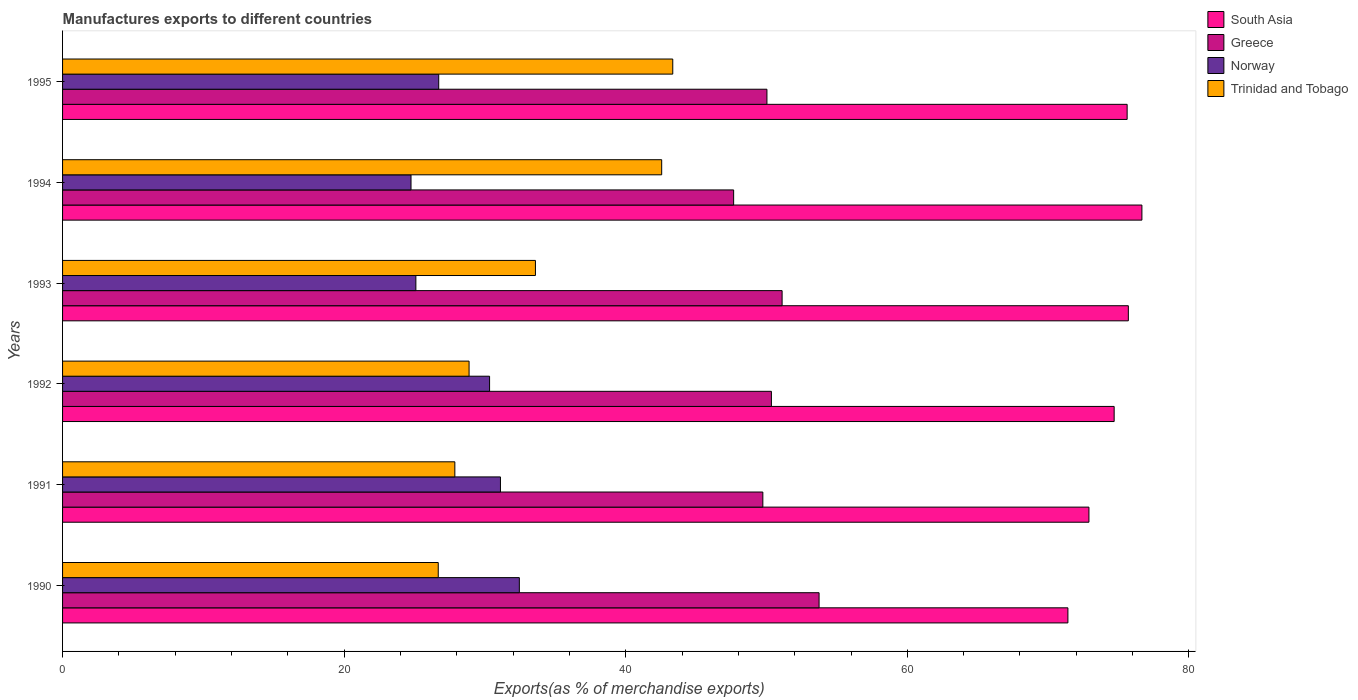How many different coloured bars are there?
Your answer should be compact. 4. How many groups of bars are there?
Offer a terse response. 6. How many bars are there on the 4th tick from the top?
Your answer should be compact. 4. How many bars are there on the 3rd tick from the bottom?
Make the answer very short. 4. In how many cases, is the number of bars for a given year not equal to the number of legend labels?
Provide a short and direct response. 0. What is the percentage of exports to different countries in South Asia in 1991?
Offer a very short reply. 72.9. Across all years, what is the maximum percentage of exports to different countries in South Asia?
Offer a very short reply. 76.66. Across all years, what is the minimum percentage of exports to different countries in Norway?
Offer a terse response. 24.75. In which year was the percentage of exports to different countries in Norway maximum?
Your response must be concise. 1990. What is the total percentage of exports to different countries in Norway in the graph?
Provide a succinct answer. 170.43. What is the difference between the percentage of exports to different countries in South Asia in 1991 and that in 1993?
Your answer should be very brief. -2.8. What is the difference between the percentage of exports to different countries in Greece in 1993 and the percentage of exports to different countries in Trinidad and Tobago in 1995?
Make the answer very short. 7.77. What is the average percentage of exports to different countries in South Asia per year?
Keep it short and to the point. 74.49. In the year 1990, what is the difference between the percentage of exports to different countries in South Asia and percentage of exports to different countries in Trinidad and Tobago?
Offer a very short reply. 44.72. In how many years, is the percentage of exports to different countries in Norway greater than 28 %?
Provide a short and direct response. 3. What is the ratio of the percentage of exports to different countries in South Asia in 1994 to that in 1995?
Provide a short and direct response. 1.01. What is the difference between the highest and the second highest percentage of exports to different countries in Trinidad and Tobago?
Give a very brief answer. 0.79. What is the difference between the highest and the lowest percentage of exports to different countries in South Asia?
Your answer should be compact. 5.25. In how many years, is the percentage of exports to different countries in Trinidad and Tobago greater than the average percentage of exports to different countries in Trinidad and Tobago taken over all years?
Ensure brevity in your answer.  2. Is it the case that in every year, the sum of the percentage of exports to different countries in Trinidad and Tobago and percentage of exports to different countries in South Asia is greater than the sum of percentage of exports to different countries in Norway and percentage of exports to different countries in Greece?
Offer a very short reply. Yes. What does the 3rd bar from the top in 1994 represents?
Your answer should be compact. Greece. What does the 3rd bar from the bottom in 1990 represents?
Keep it short and to the point. Norway. Is it the case that in every year, the sum of the percentage of exports to different countries in Trinidad and Tobago and percentage of exports to different countries in South Asia is greater than the percentage of exports to different countries in Norway?
Your answer should be very brief. Yes. What is the difference between two consecutive major ticks on the X-axis?
Provide a short and direct response. 20. Does the graph contain grids?
Offer a terse response. No. Where does the legend appear in the graph?
Ensure brevity in your answer.  Top right. How many legend labels are there?
Keep it short and to the point. 4. What is the title of the graph?
Keep it short and to the point. Manufactures exports to different countries. Does "Latvia" appear as one of the legend labels in the graph?
Provide a succinct answer. No. What is the label or title of the X-axis?
Offer a very short reply. Exports(as % of merchandise exports). What is the Exports(as % of merchandise exports) in South Asia in 1990?
Provide a succinct answer. 71.4. What is the Exports(as % of merchandise exports) in Greece in 1990?
Ensure brevity in your answer.  53.73. What is the Exports(as % of merchandise exports) in Norway in 1990?
Provide a short and direct response. 32.44. What is the Exports(as % of merchandise exports) in Trinidad and Tobago in 1990?
Give a very brief answer. 26.68. What is the Exports(as % of merchandise exports) in South Asia in 1991?
Make the answer very short. 72.9. What is the Exports(as % of merchandise exports) in Greece in 1991?
Provide a short and direct response. 49.74. What is the Exports(as % of merchandise exports) in Norway in 1991?
Your response must be concise. 31.1. What is the Exports(as % of merchandise exports) in Trinidad and Tobago in 1991?
Keep it short and to the point. 27.86. What is the Exports(as % of merchandise exports) in South Asia in 1992?
Your answer should be compact. 74.69. What is the Exports(as % of merchandise exports) in Greece in 1992?
Offer a very short reply. 50.34. What is the Exports(as % of merchandise exports) of Norway in 1992?
Your response must be concise. 30.33. What is the Exports(as % of merchandise exports) of Trinidad and Tobago in 1992?
Offer a very short reply. 28.87. What is the Exports(as % of merchandise exports) in South Asia in 1993?
Ensure brevity in your answer.  75.7. What is the Exports(as % of merchandise exports) in Greece in 1993?
Provide a short and direct response. 51.1. What is the Exports(as % of merchandise exports) of Norway in 1993?
Ensure brevity in your answer.  25.09. What is the Exports(as % of merchandise exports) of Trinidad and Tobago in 1993?
Provide a succinct answer. 33.58. What is the Exports(as % of merchandise exports) of South Asia in 1994?
Your answer should be compact. 76.66. What is the Exports(as % of merchandise exports) of Greece in 1994?
Your answer should be compact. 47.66. What is the Exports(as % of merchandise exports) in Norway in 1994?
Provide a short and direct response. 24.75. What is the Exports(as % of merchandise exports) in Trinidad and Tobago in 1994?
Your response must be concise. 42.55. What is the Exports(as % of merchandise exports) of South Asia in 1995?
Provide a short and direct response. 75.61. What is the Exports(as % of merchandise exports) in Greece in 1995?
Offer a terse response. 50.03. What is the Exports(as % of merchandise exports) of Norway in 1995?
Provide a short and direct response. 26.72. What is the Exports(as % of merchandise exports) of Trinidad and Tobago in 1995?
Your answer should be compact. 43.34. Across all years, what is the maximum Exports(as % of merchandise exports) in South Asia?
Your answer should be compact. 76.66. Across all years, what is the maximum Exports(as % of merchandise exports) in Greece?
Your response must be concise. 53.73. Across all years, what is the maximum Exports(as % of merchandise exports) in Norway?
Offer a very short reply. 32.44. Across all years, what is the maximum Exports(as % of merchandise exports) in Trinidad and Tobago?
Your answer should be very brief. 43.34. Across all years, what is the minimum Exports(as % of merchandise exports) of South Asia?
Provide a short and direct response. 71.4. Across all years, what is the minimum Exports(as % of merchandise exports) in Greece?
Give a very brief answer. 47.66. Across all years, what is the minimum Exports(as % of merchandise exports) of Norway?
Ensure brevity in your answer.  24.75. Across all years, what is the minimum Exports(as % of merchandise exports) in Trinidad and Tobago?
Your response must be concise. 26.68. What is the total Exports(as % of merchandise exports) in South Asia in the graph?
Ensure brevity in your answer.  446.95. What is the total Exports(as % of merchandise exports) in Greece in the graph?
Provide a short and direct response. 302.61. What is the total Exports(as % of merchandise exports) in Norway in the graph?
Your response must be concise. 170.43. What is the total Exports(as % of merchandise exports) of Trinidad and Tobago in the graph?
Your answer should be compact. 202.89. What is the difference between the Exports(as % of merchandise exports) in South Asia in 1990 and that in 1991?
Provide a short and direct response. -1.49. What is the difference between the Exports(as % of merchandise exports) in Greece in 1990 and that in 1991?
Offer a terse response. 3.99. What is the difference between the Exports(as % of merchandise exports) of Norway in 1990 and that in 1991?
Give a very brief answer. 1.34. What is the difference between the Exports(as % of merchandise exports) in Trinidad and Tobago in 1990 and that in 1991?
Offer a terse response. -1.18. What is the difference between the Exports(as % of merchandise exports) of South Asia in 1990 and that in 1992?
Your answer should be very brief. -3.28. What is the difference between the Exports(as % of merchandise exports) in Greece in 1990 and that in 1992?
Provide a short and direct response. 3.39. What is the difference between the Exports(as % of merchandise exports) of Norway in 1990 and that in 1992?
Ensure brevity in your answer.  2.11. What is the difference between the Exports(as % of merchandise exports) in Trinidad and Tobago in 1990 and that in 1992?
Offer a very short reply. -2.19. What is the difference between the Exports(as % of merchandise exports) in South Asia in 1990 and that in 1993?
Ensure brevity in your answer.  -4.29. What is the difference between the Exports(as % of merchandise exports) in Greece in 1990 and that in 1993?
Offer a terse response. 2.63. What is the difference between the Exports(as % of merchandise exports) in Norway in 1990 and that in 1993?
Provide a succinct answer. 7.35. What is the difference between the Exports(as % of merchandise exports) of Trinidad and Tobago in 1990 and that in 1993?
Your answer should be very brief. -6.9. What is the difference between the Exports(as % of merchandise exports) in South Asia in 1990 and that in 1994?
Offer a terse response. -5.25. What is the difference between the Exports(as % of merchandise exports) of Greece in 1990 and that in 1994?
Make the answer very short. 6.07. What is the difference between the Exports(as % of merchandise exports) in Norway in 1990 and that in 1994?
Your answer should be compact. 7.69. What is the difference between the Exports(as % of merchandise exports) of Trinidad and Tobago in 1990 and that in 1994?
Make the answer very short. -15.87. What is the difference between the Exports(as % of merchandise exports) in South Asia in 1990 and that in 1995?
Offer a very short reply. -4.21. What is the difference between the Exports(as % of merchandise exports) of Greece in 1990 and that in 1995?
Offer a very short reply. 3.7. What is the difference between the Exports(as % of merchandise exports) of Norway in 1990 and that in 1995?
Ensure brevity in your answer.  5.73. What is the difference between the Exports(as % of merchandise exports) of Trinidad and Tobago in 1990 and that in 1995?
Make the answer very short. -16.66. What is the difference between the Exports(as % of merchandise exports) in South Asia in 1991 and that in 1992?
Offer a terse response. -1.79. What is the difference between the Exports(as % of merchandise exports) of Greece in 1991 and that in 1992?
Give a very brief answer. -0.61. What is the difference between the Exports(as % of merchandise exports) in Norway in 1991 and that in 1992?
Keep it short and to the point. 0.77. What is the difference between the Exports(as % of merchandise exports) of Trinidad and Tobago in 1991 and that in 1992?
Ensure brevity in your answer.  -1.01. What is the difference between the Exports(as % of merchandise exports) in South Asia in 1991 and that in 1993?
Your answer should be compact. -2.8. What is the difference between the Exports(as % of merchandise exports) in Greece in 1991 and that in 1993?
Ensure brevity in your answer.  -1.37. What is the difference between the Exports(as % of merchandise exports) in Norway in 1991 and that in 1993?
Your answer should be compact. 6.01. What is the difference between the Exports(as % of merchandise exports) of Trinidad and Tobago in 1991 and that in 1993?
Your answer should be very brief. -5.72. What is the difference between the Exports(as % of merchandise exports) in South Asia in 1991 and that in 1994?
Keep it short and to the point. -3.76. What is the difference between the Exports(as % of merchandise exports) in Greece in 1991 and that in 1994?
Keep it short and to the point. 2.07. What is the difference between the Exports(as % of merchandise exports) of Norway in 1991 and that in 1994?
Provide a succinct answer. 6.35. What is the difference between the Exports(as % of merchandise exports) in Trinidad and Tobago in 1991 and that in 1994?
Give a very brief answer. -14.69. What is the difference between the Exports(as % of merchandise exports) in South Asia in 1991 and that in 1995?
Your response must be concise. -2.71. What is the difference between the Exports(as % of merchandise exports) in Greece in 1991 and that in 1995?
Your answer should be very brief. -0.29. What is the difference between the Exports(as % of merchandise exports) of Norway in 1991 and that in 1995?
Provide a short and direct response. 4.38. What is the difference between the Exports(as % of merchandise exports) of Trinidad and Tobago in 1991 and that in 1995?
Your answer should be compact. -15.48. What is the difference between the Exports(as % of merchandise exports) in South Asia in 1992 and that in 1993?
Offer a terse response. -1.01. What is the difference between the Exports(as % of merchandise exports) in Greece in 1992 and that in 1993?
Your answer should be very brief. -0.76. What is the difference between the Exports(as % of merchandise exports) of Norway in 1992 and that in 1993?
Provide a succinct answer. 5.23. What is the difference between the Exports(as % of merchandise exports) of Trinidad and Tobago in 1992 and that in 1993?
Offer a terse response. -4.71. What is the difference between the Exports(as % of merchandise exports) of South Asia in 1992 and that in 1994?
Offer a very short reply. -1.97. What is the difference between the Exports(as % of merchandise exports) in Greece in 1992 and that in 1994?
Offer a terse response. 2.68. What is the difference between the Exports(as % of merchandise exports) of Norway in 1992 and that in 1994?
Provide a succinct answer. 5.58. What is the difference between the Exports(as % of merchandise exports) of Trinidad and Tobago in 1992 and that in 1994?
Your answer should be compact. -13.68. What is the difference between the Exports(as % of merchandise exports) of South Asia in 1992 and that in 1995?
Make the answer very short. -0.92. What is the difference between the Exports(as % of merchandise exports) in Greece in 1992 and that in 1995?
Offer a terse response. 0.32. What is the difference between the Exports(as % of merchandise exports) of Norway in 1992 and that in 1995?
Your answer should be compact. 3.61. What is the difference between the Exports(as % of merchandise exports) of Trinidad and Tobago in 1992 and that in 1995?
Provide a short and direct response. -14.47. What is the difference between the Exports(as % of merchandise exports) of South Asia in 1993 and that in 1994?
Your answer should be compact. -0.96. What is the difference between the Exports(as % of merchandise exports) in Greece in 1993 and that in 1994?
Give a very brief answer. 3.44. What is the difference between the Exports(as % of merchandise exports) in Norway in 1993 and that in 1994?
Offer a very short reply. 0.35. What is the difference between the Exports(as % of merchandise exports) of Trinidad and Tobago in 1993 and that in 1994?
Your answer should be very brief. -8.97. What is the difference between the Exports(as % of merchandise exports) in South Asia in 1993 and that in 1995?
Ensure brevity in your answer.  0.09. What is the difference between the Exports(as % of merchandise exports) of Greece in 1993 and that in 1995?
Give a very brief answer. 1.08. What is the difference between the Exports(as % of merchandise exports) in Norway in 1993 and that in 1995?
Give a very brief answer. -1.62. What is the difference between the Exports(as % of merchandise exports) of Trinidad and Tobago in 1993 and that in 1995?
Your answer should be compact. -9.75. What is the difference between the Exports(as % of merchandise exports) of South Asia in 1994 and that in 1995?
Make the answer very short. 1.05. What is the difference between the Exports(as % of merchandise exports) in Greece in 1994 and that in 1995?
Keep it short and to the point. -2.36. What is the difference between the Exports(as % of merchandise exports) of Norway in 1994 and that in 1995?
Offer a terse response. -1.97. What is the difference between the Exports(as % of merchandise exports) of Trinidad and Tobago in 1994 and that in 1995?
Offer a terse response. -0.79. What is the difference between the Exports(as % of merchandise exports) in South Asia in 1990 and the Exports(as % of merchandise exports) in Greece in 1991?
Keep it short and to the point. 21.67. What is the difference between the Exports(as % of merchandise exports) in South Asia in 1990 and the Exports(as % of merchandise exports) in Norway in 1991?
Your answer should be very brief. 40.3. What is the difference between the Exports(as % of merchandise exports) in South Asia in 1990 and the Exports(as % of merchandise exports) in Trinidad and Tobago in 1991?
Offer a very short reply. 43.54. What is the difference between the Exports(as % of merchandise exports) in Greece in 1990 and the Exports(as % of merchandise exports) in Norway in 1991?
Give a very brief answer. 22.63. What is the difference between the Exports(as % of merchandise exports) of Greece in 1990 and the Exports(as % of merchandise exports) of Trinidad and Tobago in 1991?
Your answer should be compact. 25.87. What is the difference between the Exports(as % of merchandise exports) of Norway in 1990 and the Exports(as % of merchandise exports) of Trinidad and Tobago in 1991?
Provide a short and direct response. 4.58. What is the difference between the Exports(as % of merchandise exports) in South Asia in 1990 and the Exports(as % of merchandise exports) in Greece in 1992?
Provide a succinct answer. 21.06. What is the difference between the Exports(as % of merchandise exports) of South Asia in 1990 and the Exports(as % of merchandise exports) of Norway in 1992?
Your answer should be compact. 41.08. What is the difference between the Exports(as % of merchandise exports) in South Asia in 1990 and the Exports(as % of merchandise exports) in Trinidad and Tobago in 1992?
Provide a short and direct response. 42.53. What is the difference between the Exports(as % of merchandise exports) of Greece in 1990 and the Exports(as % of merchandise exports) of Norway in 1992?
Make the answer very short. 23.4. What is the difference between the Exports(as % of merchandise exports) in Greece in 1990 and the Exports(as % of merchandise exports) in Trinidad and Tobago in 1992?
Make the answer very short. 24.86. What is the difference between the Exports(as % of merchandise exports) of Norway in 1990 and the Exports(as % of merchandise exports) of Trinidad and Tobago in 1992?
Offer a terse response. 3.57. What is the difference between the Exports(as % of merchandise exports) of South Asia in 1990 and the Exports(as % of merchandise exports) of Greece in 1993?
Keep it short and to the point. 20.3. What is the difference between the Exports(as % of merchandise exports) of South Asia in 1990 and the Exports(as % of merchandise exports) of Norway in 1993?
Your answer should be very brief. 46.31. What is the difference between the Exports(as % of merchandise exports) of South Asia in 1990 and the Exports(as % of merchandise exports) of Trinidad and Tobago in 1993?
Your response must be concise. 37.82. What is the difference between the Exports(as % of merchandise exports) of Greece in 1990 and the Exports(as % of merchandise exports) of Norway in 1993?
Offer a very short reply. 28.64. What is the difference between the Exports(as % of merchandise exports) of Greece in 1990 and the Exports(as % of merchandise exports) of Trinidad and Tobago in 1993?
Offer a terse response. 20.15. What is the difference between the Exports(as % of merchandise exports) of Norway in 1990 and the Exports(as % of merchandise exports) of Trinidad and Tobago in 1993?
Make the answer very short. -1.14. What is the difference between the Exports(as % of merchandise exports) in South Asia in 1990 and the Exports(as % of merchandise exports) in Greece in 1994?
Ensure brevity in your answer.  23.74. What is the difference between the Exports(as % of merchandise exports) in South Asia in 1990 and the Exports(as % of merchandise exports) in Norway in 1994?
Provide a short and direct response. 46.66. What is the difference between the Exports(as % of merchandise exports) of South Asia in 1990 and the Exports(as % of merchandise exports) of Trinidad and Tobago in 1994?
Offer a terse response. 28.85. What is the difference between the Exports(as % of merchandise exports) in Greece in 1990 and the Exports(as % of merchandise exports) in Norway in 1994?
Ensure brevity in your answer.  28.98. What is the difference between the Exports(as % of merchandise exports) in Greece in 1990 and the Exports(as % of merchandise exports) in Trinidad and Tobago in 1994?
Ensure brevity in your answer.  11.18. What is the difference between the Exports(as % of merchandise exports) in Norway in 1990 and the Exports(as % of merchandise exports) in Trinidad and Tobago in 1994?
Provide a short and direct response. -10.11. What is the difference between the Exports(as % of merchandise exports) of South Asia in 1990 and the Exports(as % of merchandise exports) of Greece in 1995?
Provide a short and direct response. 21.38. What is the difference between the Exports(as % of merchandise exports) in South Asia in 1990 and the Exports(as % of merchandise exports) in Norway in 1995?
Give a very brief answer. 44.69. What is the difference between the Exports(as % of merchandise exports) of South Asia in 1990 and the Exports(as % of merchandise exports) of Trinidad and Tobago in 1995?
Provide a succinct answer. 28.07. What is the difference between the Exports(as % of merchandise exports) of Greece in 1990 and the Exports(as % of merchandise exports) of Norway in 1995?
Your answer should be very brief. 27.01. What is the difference between the Exports(as % of merchandise exports) of Greece in 1990 and the Exports(as % of merchandise exports) of Trinidad and Tobago in 1995?
Your answer should be very brief. 10.39. What is the difference between the Exports(as % of merchandise exports) in Norway in 1990 and the Exports(as % of merchandise exports) in Trinidad and Tobago in 1995?
Make the answer very short. -10.9. What is the difference between the Exports(as % of merchandise exports) of South Asia in 1991 and the Exports(as % of merchandise exports) of Greece in 1992?
Provide a short and direct response. 22.55. What is the difference between the Exports(as % of merchandise exports) in South Asia in 1991 and the Exports(as % of merchandise exports) in Norway in 1992?
Ensure brevity in your answer.  42.57. What is the difference between the Exports(as % of merchandise exports) of South Asia in 1991 and the Exports(as % of merchandise exports) of Trinidad and Tobago in 1992?
Your answer should be very brief. 44.02. What is the difference between the Exports(as % of merchandise exports) of Greece in 1991 and the Exports(as % of merchandise exports) of Norway in 1992?
Your answer should be very brief. 19.41. What is the difference between the Exports(as % of merchandise exports) of Greece in 1991 and the Exports(as % of merchandise exports) of Trinidad and Tobago in 1992?
Ensure brevity in your answer.  20.86. What is the difference between the Exports(as % of merchandise exports) in Norway in 1991 and the Exports(as % of merchandise exports) in Trinidad and Tobago in 1992?
Give a very brief answer. 2.23. What is the difference between the Exports(as % of merchandise exports) in South Asia in 1991 and the Exports(as % of merchandise exports) in Greece in 1993?
Your answer should be very brief. 21.79. What is the difference between the Exports(as % of merchandise exports) of South Asia in 1991 and the Exports(as % of merchandise exports) of Norway in 1993?
Your answer should be compact. 47.8. What is the difference between the Exports(as % of merchandise exports) in South Asia in 1991 and the Exports(as % of merchandise exports) in Trinidad and Tobago in 1993?
Provide a short and direct response. 39.31. What is the difference between the Exports(as % of merchandise exports) of Greece in 1991 and the Exports(as % of merchandise exports) of Norway in 1993?
Offer a terse response. 24.64. What is the difference between the Exports(as % of merchandise exports) of Greece in 1991 and the Exports(as % of merchandise exports) of Trinidad and Tobago in 1993?
Provide a succinct answer. 16.15. What is the difference between the Exports(as % of merchandise exports) of Norway in 1991 and the Exports(as % of merchandise exports) of Trinidad and Tobago in 1993?
Your answer should be compact. -2.48. What is the difference between the Exports(as % of merchandise exports) of South Asia in 1991 and the Exports(as % of merchandise exports) of Greece in 1994?
Ensure brevity in your answer.  25.23. What is the difference between the Exports(as % of merchandise exports) of South Asia in 1991 and the Exports(as % of merchandise exports) of Norway in 1994?
Make the answer very short. 48.15. What is the difference between the Exports(as % of merchandise exports) of South Asia in 1991 and the Exports(as % of merchandise exports) of Trinidad and Tobago in 1994?
Your response must be concise. 30.34. What is the difference between the Exports(as % of merchandise exports) in Greece in 1991 and the Exports(as % of merchandise exports) in Norway in 1994?
Keep it short and to the point. 24.99. What is the difference between the Exports(as % of merchandise exports) of Greece in 1991 and the Exports(as % of merchandise exports) of Trinidad and Tobago in 1994?
Provide a short and direct response. 7.18. What is the difference between the Exports(as % of merchandise exports) in Norway in 1991 and the Exports(as % of merchandise exports) in Trinidad and Tobago in 1994?
Provide a succinct answer. -11.45. What is the difference between the Exports(as % of merchandise exports) of South Asia in 1991 and the Exports(as % of merchandise exports) of Greece in 1995?
Give a very brief answer. 22.87. What is the difference between the Exports(as % of merchandise exports) of South Asia in 1991 and the Exports(as % of merchandise exports) of Norway in 1995?
Keep it short and to the point. 46.18. What is the difference between the Exports(as % of merchandise exports) of South Asia in 1991 and the Exports(as % of merchandise exports) of Trinidad and Tobago in 1995?
Offer a terse response. 29.56. What is the difference between the Exports(as % of merchandise exports) of Greece in 1991 and the Exports(as % of merchandise exports) of Norway in 1995?
Keep it short and to the point. 23.02. What is the difference between the Exports(as % of merchandise exports) in Greece in 1991 and the Exports(as % of merchandise exports) in Trinidad and Tobago in 1995?
Provide a succinct answer. 6.4. What is the difference between the Exports(as % of merchandise exports) in Norway in 1991 and the Exports(as % of merchandise exports) in Trinidad and Tobago in 1995?
Your response must be concise. -12.24. What is the difference between the Exports(as % of merchandise exports) in South Asia in 1992 and the Exports(as % of merchandise exports) in Greece in 1993?
Your response must be concise. 23.58. What is the difference between the Exports(as % of merchandise exports) in South Asia in 1992 and the Exports(as % of merchandise exports) in Norway in 1993?
Give a very brief answer. 49.59. What is the difference between the Exports(as % of merchandise exports) of South Asia in 1992 and the Exports(as % of merchandise exports) of Trinidad and Tobago in 1993?
Make the answer very short. 41.1. What is the difference between the Exports(as % of merchandise exports) in Greece in 1992 and the Exports(as % of merchandise exports) in Norway in 1993?
Offer a very short reply. 25.25. What is the difference between the Exports(as % of merchandise exports) in Greece in 1992 and the Exports(as % of merchandise exports) in Trinidad and Tobago in 1993?
Provide a short and direct response. 16.76. What is the difference between the Exports(as % of merchandise exports) in Norway in 1992 and the Exports(as % of merchandise exports) in Trinidad and Tobago in 1993?
Your response must be concise. -3.26. What is the difference between the Exports(as % of merchandise exports) in South Asia in 1992 and the Exports(as % of merchandise exports) in Greece in 1994?
Offer a very short reply. 27.02. What is the difference between the Exports(as % of merchandise exports) in South Asia in 1992 and the Exports(as % of merchandise exports) in Norway in 1994?
Offer a very short reply. 49.94. What is the difference between the Exports(as % of merchandise exports) in South Asia in 1992 and the Exports(as % of merchandise exports) in Trinidad and Tobago in 1994?
Offer a terse response. 32.14. What is the difference between the Exports(as % of merchandise exports) in Greece in 1992 and the Exports(as % of merchandise exports) in Norway in 1994?
Your answer should be very brief. 25.6. What is the difference between the Exports(as % of merchandise exports) in Greece in 1992 and the Exports(as % of merchandise exports) in Trinidad and Tobago in 1994?
Provide a short and direct response. 7.79. What is the difference between the Exports(as % of merchandise exports) in Norway in 1992 and the Exports(as % of merchandise exports) in Trinidad and Tobago in 1994?
Provide a short and direct response. -12.22. What is the difference between the Exports(as % of merchandise exports) of South Asia in 1992 and the Exports(as % of merchandise exports) of Greece in 1995?
Ensure brevity in your answer.  24.66. What is the difference between the Exports(as % of merchandise exports) in South Asia in 1992 and the Exports(as % of merchandise exports) in Norway in 1995?
Your answer should be very brief. 47.97. What is the difference between the Exports(as % of merchandise exports) in South Asia in 1992 and the Exports(as % of merchandise exports) in Trinidad and Tobago in 1995?
Your response must be concise. 31.35. What is the difference between the Exports(as % of merchandise exports) in Greece in 1992 and the Exports(as % of merchandise exports) in Norway in 1995?
Your answer should be compact. 23.63. What is the difference between the Exports(as % of merchandise exports) in Greece in 1992 and the Exports(as % of merchandise exports) in Trinidad and Tobago in 1995?
Offer a terse response. 7.01. What is the difference between the Exports(as % of merchandise exports) of Norway in 1992 and the Exports(as % of merchandise exports) of Trinidad and Tobago in 1995?
Give a very brief answer. -13.01. What is the difference between the Exports(as % of merchandise exports) of South Asia in 1993 and the Exports(as % of merchandise exports) of Greece in 1994?
Provide a succinct answer. 28.03. What is the difference between the Exports(as % of merchandise exports) of South Asia in 1993 and the Exports(as % of merchandise exports) of Norway in 1994?
Keep it short and to the point. 50.95. What is the difference between the Exports(as % of merchandise exports) of South Asia in 1993 and the Exports(as % of merchandise exports) of Trinidad and Tobago in 1994?
Offer a terse response. 33.14. What is the difference between the Exports(as % of merchandise exports) in Greece in 1993 and the Exports(as % of merchandise exports) in Norway in 1994?
Provide a succinct answer. 26.36. What is the difference between the Exports(as % of merchandise exports) in Greece in 1993 and the Exports(as % of merchandise exports) in Trinidad and Tobago in 1994?
Your answer should be very brief. 8.55. What is the difference between the Exports(as % of merchandise exports) in Norway in 1993 and the Exports(as % of merchandise exports) in Trinidad and Tobago in 1994?
Offer a terse response. -17.46. What is the difference between the Exports(as % of merchandise exports) in South Asia in 1993 and the Exports(as % of merchandise exports) in Greece in 1995?
Provide a succinct answer. 25.67. What is the difference between the Exports(as % of merchandise exports) of South Asia in 1993 and the Exports(as % of merchandise exports) of Norway in 1995?
Your answer should be very brief. 48.98. What is the difference between the Exports(as % of merchandise exports) in South Asia in 1993 and the Exports(as % of merchandise exports) in Trinidad and Tobago in 1995?
Your answer should be compact. 32.36. What is the difference between the Exports(as % of merchandise exports) in Greece in 1993 and the Exports(as % of merchandise exports) in Norway in 1995?
Give a very brief answer. 24.39. What is the difference between the Exports(as % of merchandise exports) in Greece in 1993 and the Exports(as % of merchandise exports) in Trinidad and Tobago in 1995?
Keep it short and to the point. 7.77. What is the difference between the Exports(as % of merchandise exports) of Norway in 1993 and the Exports(as % of merchandise exports) of Trinidad and Tobago in 1995?
Keep it short and to the point. -18.25. What is the difference between the Exports(as % of merchandise exports) of South Asia in 1994 and the Exports(as % of merchandise exports) of Greece in 1995?
Your answer should be very brief. 26.63. What is the difference between the Exports(as % of merchandise exports) in South Asia in 1994 and the Exports(as % of merchandise exports) in Norway in 1995?
Make the answer very short. 49.94. What is the difference between the Exports(as % of merchandise exports) in South Asia in 1994 and the Exports(as % of merchandise exports) in Trinidad and Tobago in 1995?
Offer a terse response. 33.32. What is the difference between the Exports(as % of merchandise exports) of Greece in 1994 and the Exports(as % of merchandise exports) of Norway in 1995?
Provide a succinct answer. 20.95. What is the difference between the Exports(as % of merchandise exports) of Greece in 1994 and the Exports(as % of merchandise exports) of Trinidad and Tobago in 1995?
Give a very brief answer. 4.32. What is the difference between the Exports(as % of merchandise exports) in Norway in 1994 and the Exports(as % of merchandise exports) in Trinidad and Tobago in 1995?
Provide a succinct answer. -18.59. What is the average Exports(as % of merchandise exports) in South Asia per year?
Provide a short and direct response. 74.49. What is the average Exports(as % of merchandise exports) in Greece per year?
Your response must be concise. 50.43. What is the average Exports(as % of merchandise exports) in Norway per year?
Keep it short and to the point. 28.4. What is the average Exports(as % of merchandise exports) in Trinidad and Tobago per year?
Your answer should be very brief. 33.82. In the year 1990, what is the difference between the Exports(as % of merchandise exports) of South Asia and Exports(as % of merchandise exports) of Greece?
Make the answer very short. 17.67. In the year 1990, what is the difference between the Exports(as % of merchandise exports) of South Asia and Exports(as % of merchandise exports) of Norway?
Make the answer very short. 38.96. In the year 1990, what is the difference between the Exports(as % of merchandise exports) in South Asia and Exports(as % of merchandise exports) in Trinidad and Tobago?
Your answer should be very brief. 44.72. In the year 1990, what is the difference between the Exports(as % of merchandise exports) of Greece and Exports(as % of merchandise exports) of Norway?
Offer a terse response. 21.29. In the year 1990, what is the difference between the Exports(as % of merchandise exports) in Greece and Exports(as % of merchandise exports) in Trinidad and Tobago?
Keep it short and to the point. 27.05. In the year 1990, what is the difference between the Exports(as % of merchandise exports) of Norway and Exports(as % of merchandise exports) of Trinidad and Tobago?
Offer a very short reply. 5.76. In the year 1991, what is the difference between the Exports(as % of merchandise exports) of South Asia and Exports(as % of merchandise exports) of Greece?
Offer a very short reply. 23.16. In the year 1991, what is the difference between the Exports(as % of merchandise exports) in South Asia and Exports(as % of merchandise exports) in Norway?
Offer a terse response. 41.8. In the year 1991, what is the difference between the Exports(as % of merchandise exports) in South Asia and Exports(as % of merchandise exports) in Trinidad and Tobago?
Keep it short and to the point. 45.04. In the year 1991, what is the difference between the Exports(as % of merchandise exports) of Greece and Exports(as % of merchandise exports) of Norway?
Your response must be concise. 18.64. In the year 1991, what is the difference between the Exports(as % of merchandise exports) of Greece and Exports(as % of merchandise exports) of Trinidad and Tobago?
Your answer should be very brief. 21.87. In the year 1991, what is the difference between the Exports(as % of merchandise exports) in Norway and Exports(as % of merchandise exports) in Trinidad and Tobago?
Give a very brief answer. 3.24. In the year 1992, what is the difference between the Exports(as % of merchandise exports) in South Asia and Exports(as % of merchandise exports) in Greece?
Make the answer very short. 24.34. In the year 1992, what is the difference between the Exports(as % of merchandise exports) in South Asia and Exports(as % of merchandise exports) in Norway?
Provide a short and direct response. 44.36. In the year 1992, what is the difference between the Exports(as % of merchandise exports) in South Asia and Exports(as % of merchandise exports) in Trinidad and Tobago?
Provide a succinct answer. 45.82. In the year 1992, what is the difference between the Exports(as % of merchandise exports) of Greece and Exports(as % of merchandise exports) of Norway?
Keep it short and to the point. 20.02. In the year 1992, what is the difference between the Exports(as % of merchandise exports) of Greece and Exports(as % of merchandise exports) of Trinidad and Tobago?
Ensure brevity in your answer.  21.47. In the year 1992, what is the difference between the Exports(as % of merchandise exports) of Norway and Exports(as % of merchandise exports) of Trinidad and Tobago?
Offer a very short reply. 1.46. In the year 1993, what is the difference between the Exports(as % of merchandise exports) in South Asia and Exports(as % of merchandise exports) in Greece?
Your answer should be very brief. 24.59. In the year 1993, what is the difference between the Exports(as % of merchandise exports) of South Asia and Exports(as % of merchandise exports) of Norway?
Offer a terse response. 50.6. In the year 1993, what is the difference between the Exports(as % of merchandise exports) in South Asia and Exports(as % of merchandise exports) in Trinidad and Tobago?
Ensure brevity in your answer.  42.11. In the year 1993, what is the difference between the Exports(as % of merchandise exports) of Greece and Exports(as % of merchandise exports) of Norway?
Give a very brief answer. 26.01. In the year 1993, what is the difference between the Exports(as % of merchandise exports) of Greece and Exports(as % of merchandise exports) of Trinidad and Tobago?
Give a very brief answer. 17.52. In the year 1993, what is the difference between the Exports(as % of merchandise exports) in Norway and Exports(as % of merchandise exports) in Trinidad and Tobago?
Make the answer very short. -8.49. In the year 1994, what is the difference between the Exports(as % of merchandise exports) of South Asia and Exports(as % of merchandise exports) of Greece?
Give a very brief answer. 29. In the year 1994, what is the difference between the Exports(as % of merchandise exports) of South Asia and Exports(as % of merchandise exports) of Norway?
Your response must be concise. 51.91. In the year 1994, what is the difference between the Exports(as % of merchandise exports) of South Asia and Exports(as % of merchandise exports) of Trinidad and Tobago?
Your response must be concise. 34.11. In the year 1994, what is the difference between the Exports(as % of merchandise exports) of Greece and Exports(as % of merchandise exports) of Norway?
Your answer should be compact. 22.91. In the year 1994, what is the difference between the Exports(as % of merchandise exports) of Greece and Exports(as % of merchandise exports) of Trinidad and Tobago?
Give a very brief answer. 5.11. In the year 1994, what is the difference between the Exports(as % of merchandise exports) in Norway and Exports(as % of merchandise exports) in Trinidad and Tobago?
Ensure brevity in your answer.  -17.8. In the year 1995, what is the difference between the Exports(as % of merchandise exports) in South Asia and Exports(as % of merchandise exports) in Greece?
Keep it short and to the point. 25.58. In the year 1995, what is the difference between the Exports(as % of merchandise exports) of South Asia and Exports(as % of merchandise exports) of Norway?
Offer a very short reply. 48.89. In the year 1995, what is the difference between the Exports(as % of merchandise exports) of South Asia and Exports(as % of merchandise exports) of Trinidad and Tobago?
Make the answer very short. 32.27. In the year 1995, what is the difference between the Exports(as % of merchandise exports) of Greece and Exports(as % of merchandise exports) of Norway?
Make the answer very short. 23.31. In the year 1995, what is the difference between the Exports(as % of merchandise exports) in Greece and Exports(as % of merchandise exports) in Trinidad and Tobago?
Keep it short and to the point. 6.69. In the year 1995, what is the difference between the Exports(as % of merchandise exports) in Norway and Exports(as % of merchandise exports) in Trinidad and Tobago?
Keep it short and to the point. -16.62. What is the ratio of the Exports(as % of merchandise exports) of South Asia in 1990 to that in 1991?
Ensure brevity in your answer.  0.98. What is the ratio of the Exports(as % of merchandise exports) in Greece in 1990 to that in 1991?
Make the answer very short. 1.08. What is the ratio of the Exports(as % of merchandise exports) of Norway in 1990 to that in 1991?
Offer a very short reply. 1.04. What is the ratio of the Exports(as % of merchandise exports) in Trinidad and Tobago in 1990 to that in 1991?
Give a very brief answer. 0.96. What is the ratio of the Exports(as % of merchandise exports) in South Asia in 1990 to that in 1992?
Offer a terse response. 0.96. What is the ratio of the Exports(as % of merchandise exports) in Greece in 1990 to that in 1992?
Provide a short and direct response. 1.07. What is the ratio of the Exports(as % of merchandise exports) in Norway in 1990 to that in 1992?
Ensure brevity in your answer.  1.07. What is the ratio of the Exports(as % of merchandise exports) of Trinidad and Tobago in 1990 to that in 1992?
Your response must be concise. 0.92. What is the ratio of the Exports(as % of merchandise exports) of South Asia in 1990 to that in 1993?
Keep it short and to the point. 0.94. What is the ratio of the Exports(as % of merchandise exports) of Greece in 1990 to that in 1993?
Offer a terse response. 1.05. What is the ratio of the Exports(as % of merchandise exports) in Norway in 1990 to that in 1993?
Keep it short and to the point. 1.29. What is the ratio of the Exports(as % of merchandise exports) in Trinidad and Tobago in 1990 to that in 1993?
Your response must be concise. 0.79. What is the ratio of the Exports(as % of merchandise exports) in South Asia in 1990 to that in 1994?
Keep it short and to the point. 0.93. What is the ratio of the Exports(as % of merchandise exports) in Greece in 1990 to that in 1994?
Give a very brief answer. 1.13. What is the ratio of the Exports(as % of merchandise exports) in Norway in 1990 to that in 1994?
Ensure brevity in your answer.  1.31. What is the ratio of the Exports(as % of merchandise exports) in Trinidad and Tobago in 1990 to that in 1994?
Offer a very short reply. 0.63. What is the ratio of the Exports(as % of merchandise exports) in Greece in 1990 to that in 1995?
Give a very brief answer. 1.07. What is the ratio of the Exports(as % of merchandise exports) of Norway in 1990 to that in 1995?
Keep it short and to the point. 1.21. What is the ratio of the Exports(as % of merchandise exports) in Trinidad and Tobago in 1990 to that in 1995?
Provide a succinct answer. 0.62. What is the ratio of the Exports(as % of merchandise exports) in Greece in 1991 to that in 1992?
Give a very brief answer. 0.99. What is the ratio of the Exports(as % of merchandise exports) in Norway in 1991 to that in 1992?
Keep it short and to the point. 1.03. What is the ratio of the Exports(as % of merchandise exports) in Trinidad and Tobago in 1991 to that in 1992?
Ensure brevity in your answer.  0.96. What is the ratio of the Exports(as % of merchandise exports) in South Asia in 1991 to that in 1993?
Your response must be concise. 0.96. What is the ratio of the Exports(as % of merchandise exports) of Greece in 1991 to that in 1993?
Give a very brief answer. 0.97. What is the ratio of the Exports(as % of merchandise exports) in Norway in 1991 to that in 1993?
Make the answer very short. 1.24. What is the ratio of the Exports(as % of merchandise exports) of Trinidad and Tobago in 1991 to that in 1993?
Keep it short and to the point. 0.83. What is the ratio of the Exports(as % of merchandise exports) of South Asia in 1991 to that in 1994?
Provide a short and direct response. 0.95. What is the ratio of the Exports(as % of merchandise exports) of Greece in 1991 to that in 1994?
Ensure brevity in your answer.  1.04. What is the ratio of the Exports(as % of merchandise exports) in Norway in 1991 to that in 1994?
Keep it short and to the point. 1.26. What is the ratio of the Exports(as % of merchandise exports) of Trinidad and Tobago in 1991 to that in 1994?
Your answer should be very brief. 0.65. What is the ratio of the Exports(as % of merchandise exports) of South Asia in 1991 to that in 1995?
Give a very brief answer. 0.96. What is the ratio of the Exports(as % of merchandise exports) of Norway in 1991 to that in 1995?
Make the answer very short. 1.16. What is the ratio of the Exports(as % of merchandise exports) of Trinidad and Tobago in 1991 to that in 1995?
Provide a short and direct response. 0.64. What is the ratio of the Exports(as % of merchandise exports) of South Asia in 1992 to that in 1993?
Offer a very short reply. 0.99. What is the ratio of the Exports(as % of merchandise exports) in Greece in 1992 to that in 1993?
Make the answer very short. 0.99. What is the ratio of the Exports(as % of merchandise exports) in Norway in 1992 to that in 1993?
Offer a very short reply. 1.21. What is the ratio of the Exports(as % of merchandise exports) in Trinidad and Tobago in 1992 to that in 1993?
Your answer should be very brief. 0.86. What is the ratio of the Exports(as % of merchandise exports) in South Asia in 1992 to that in 1994?
Ensure brevity in your answer.  0.97. What is the ratio of the Exports(as % of merchandise exports) in Greece in 1992 to that in 1994?
Provide a succinct answer. 1.06. What is the ratio of the Exports(as % of merchandise exports) of Norway in 1992 to that in 1994?
Offer a very short reply. 1.23. What is the ratio of the Exports(as % of merchandise exports) of Trinidad and Tobago in 1992 to that in 1994?
Keep it short and to the point. 0.68. What is the ratio of the Exports(as % of merchandise exports) of South Asia in 1992 to that in 1995?
Provide a short and direct response. 0.99. What is the ratio of the Exports(as % of merchandise exports) of Norway in 1992 to that in 1995?
Offer a terse response. 1.14. What is the ratio of the Exports(as % of merchandise exports) in Trinidad and Tobago in 1992 to that in 1995?
Make the answer very short. 0.67. What is the ratio of the Exports(as % of merchandise exports) of South Asia in 1993 to that in 1994?
Keep it short and to the point. 0.99. What is the ratio of the Exports(as % of merchandise exports) of Greece in 1993 to that in 1994?
Give a very brief answer. 1.07. What is the ratio of the Exports(as % of merchandise exports) in Norway in 1993 to that in 1994?
Provide a short and direct response. 1.01. What is the ratio of the Exports(as % of merchandise exports) of Trinidad and Tobago in 1993 to that in 1994?
Your answer should be compact. 0.79. What is the ratio of the Exports(as % of merchandise exports) in South Asia in 1993 to that in 1995?
Your answer should be compact. 1. What is the ratio of the Exports(as % of merchandise exports) of Greece in 1993 to that in 1995?
Your response must be concise. 1.02. What is the ratio of the Exports(as % of merchandise exports) in Norway in 1993 to that in 1995?
Keep it short and to the point. 0.94. What is the ratio of the Exports(as % of merchandise exports) of Trinidad and Tobago in 1993 to that in 1995?
Keep it short and to the point. 0.77. What is the ratio of the Exports(as % of merchandise exports) of South Asia in 1994 to that in 1995?
Offer a terse response. 1.01. What is the ratio of the Exports(as % of merchandise exports) in Greece in 1994 to that in 1995?
Your answer should be compact. 0.95. What is the ratio of the Exports(as % of merchandise exports) in Norway in 1994 to that in 1995?
Make the answer very short. 0.93. What is the ratio of the Exports(as % of merchandise exports) of Trinidad and Tobago in 1994 to that in 1995?
Ensure brevity in your answer.  0.98. What is the difference between the highest and the second highest Exports(as % of merchandise exports) in South Asia?
Offer a terse response. 0.96. What is the difference between the highest and the second highest Exports(as % of merchandise exports) in Greece?
Your answer should be compact. 2.63. What is the difference between the highest and the second highest Exports(as % of merchandise exports) in Norway?
Keep it short and to the point. 1.34. What is the difference between the highest and the second highest Exports(as % of merchandise exports) of Trinidad and Tobago?
Offer a terse response. 0.79. What is the difference between the highest and the lowest Exports(as % of merchandise exports) of South Asia?
Ensure brevity in your answer.  5.25. What is the difference between the highest and the lowest Exports(as % of merchandise exports) of Greece?
Your response must be concise. 6.07. What is the difference between the highest and the lowest Exports(as % of merchandise exports) in Norway?
Offer a terse response. 7.69. What is the difference between the highest and the lowest Exports(as % of merchandise exports) in Trinidad and Tobago?
Ensure brevity in your answer.  16.66. 